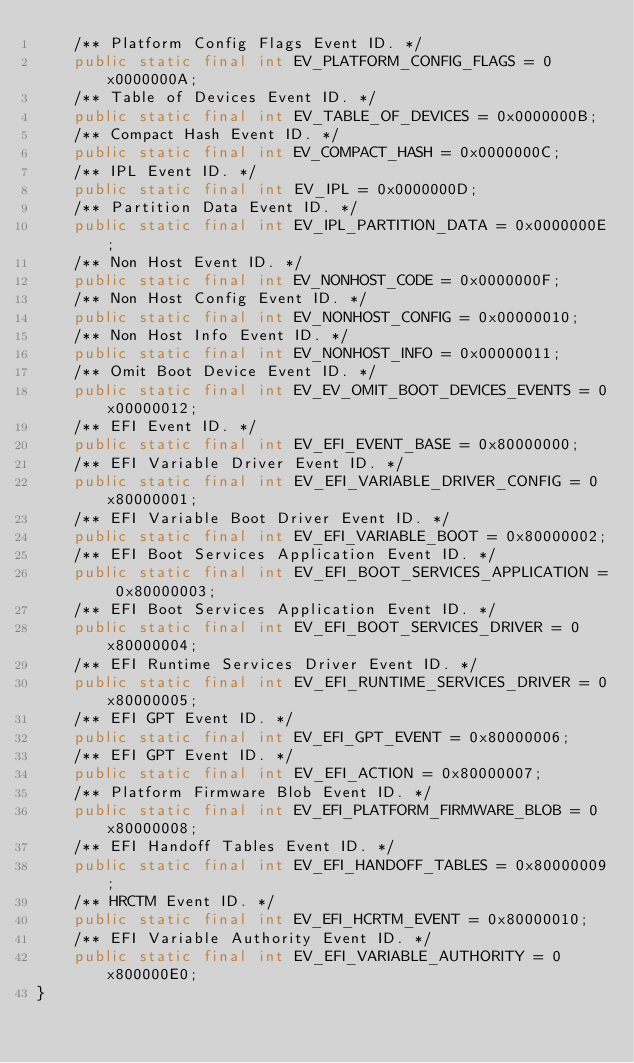Convert code to text. <code><loc_0><loc_0><loc_500><loc_500><_Java_>    /** Platform Config Flags Event ID. */
    public static final int EV_PLATFORM_CONFIG_FLAGS = 0x0000000A;
    /** Table of Devices Event ID. */
    public static final int EV_TABLE_OF_DEVICES = 0x0000000B;
    /** Compact Hash Event ID. */
    public static final int EV_COMPACT_HASH = 0x0000000C;
    /** IPL Event ID. */
    public static final int EV_IPL = 0x0000000D;
    /** Partition Data Event ID. */
    public static final int EV_IPL_PARTITION_DATA = 0x0000000E;
    /** Non Host Event ID. */
    public static final int EV_NONHOST_CODE = 0x0000000F;
    /** Non Host Config Event ID. */
    public static final int EV_NONHOST_CONFIG = 0x00000010;
    /** Non Host Info Event ID. */
    public static final int EV_NONHOST_INFO = 0x00000011;
    /** Omit Boot Device Event ID. */
    public static final int EV_EV_OMIT_BOOT_DEVICES_EVENTS = 0x00000012;
    /** EFI Event ID. */
    public static final int EV_EFI_EVENT_BASE = 0x80000000;
    /** EFI Variable Driver Event ID. */
    public static final int EV_EFI_VARIABLE_DRIVER_CONFIG = 0x80000001;
    /** EFI Variable Boot Driver Event ID. */
    public static final int EV_EFI_VARIABLE_BOOT = 0x80000002;
    /** EFI Boot Services Application Event ID. */
    public static final int EV_EFI_BOOT_SERVICES_APPLICATION = 0x80000003;
    /** EFI Boot Services Application Event ID. */
    public static final int EV_EFI_BOOT_SERVICES_DRIVER = 0x80000004;
    /** EFI Runtime Services Driver Event ID. */
    public static final int EV_EFI_RUNTIME_SERVICES_DRIVER = 0x80000005;
    /** EFI GPT Event ID. */
    public static final int EV_EFI_GPT_EVENT = 0x80000006;
    /** EFI GPT Event ID. */
    public static final int EV_EFI_ACTION = 0x80000007;
    /** Platform Firmware Blob Event ID. */
    public static final int EV_EFI_PLATFORM_FIRMWARE_BLOB = 0x80000008;
    /** EFI Handoff Tables Event ID. */
    public static final int EV_EFI_HANDOFF_TABLES = 0x80000009;
    /** HRCTM Event ID. */
    public static final int EV_EFI_HCRTM_EVENT = 0x80000010;
    /** EFI Variable Authority Event ID. */
    public static final int EV_EFI_VARIABLE_AUTHORITY = 0x800000E0;
}
</code> 